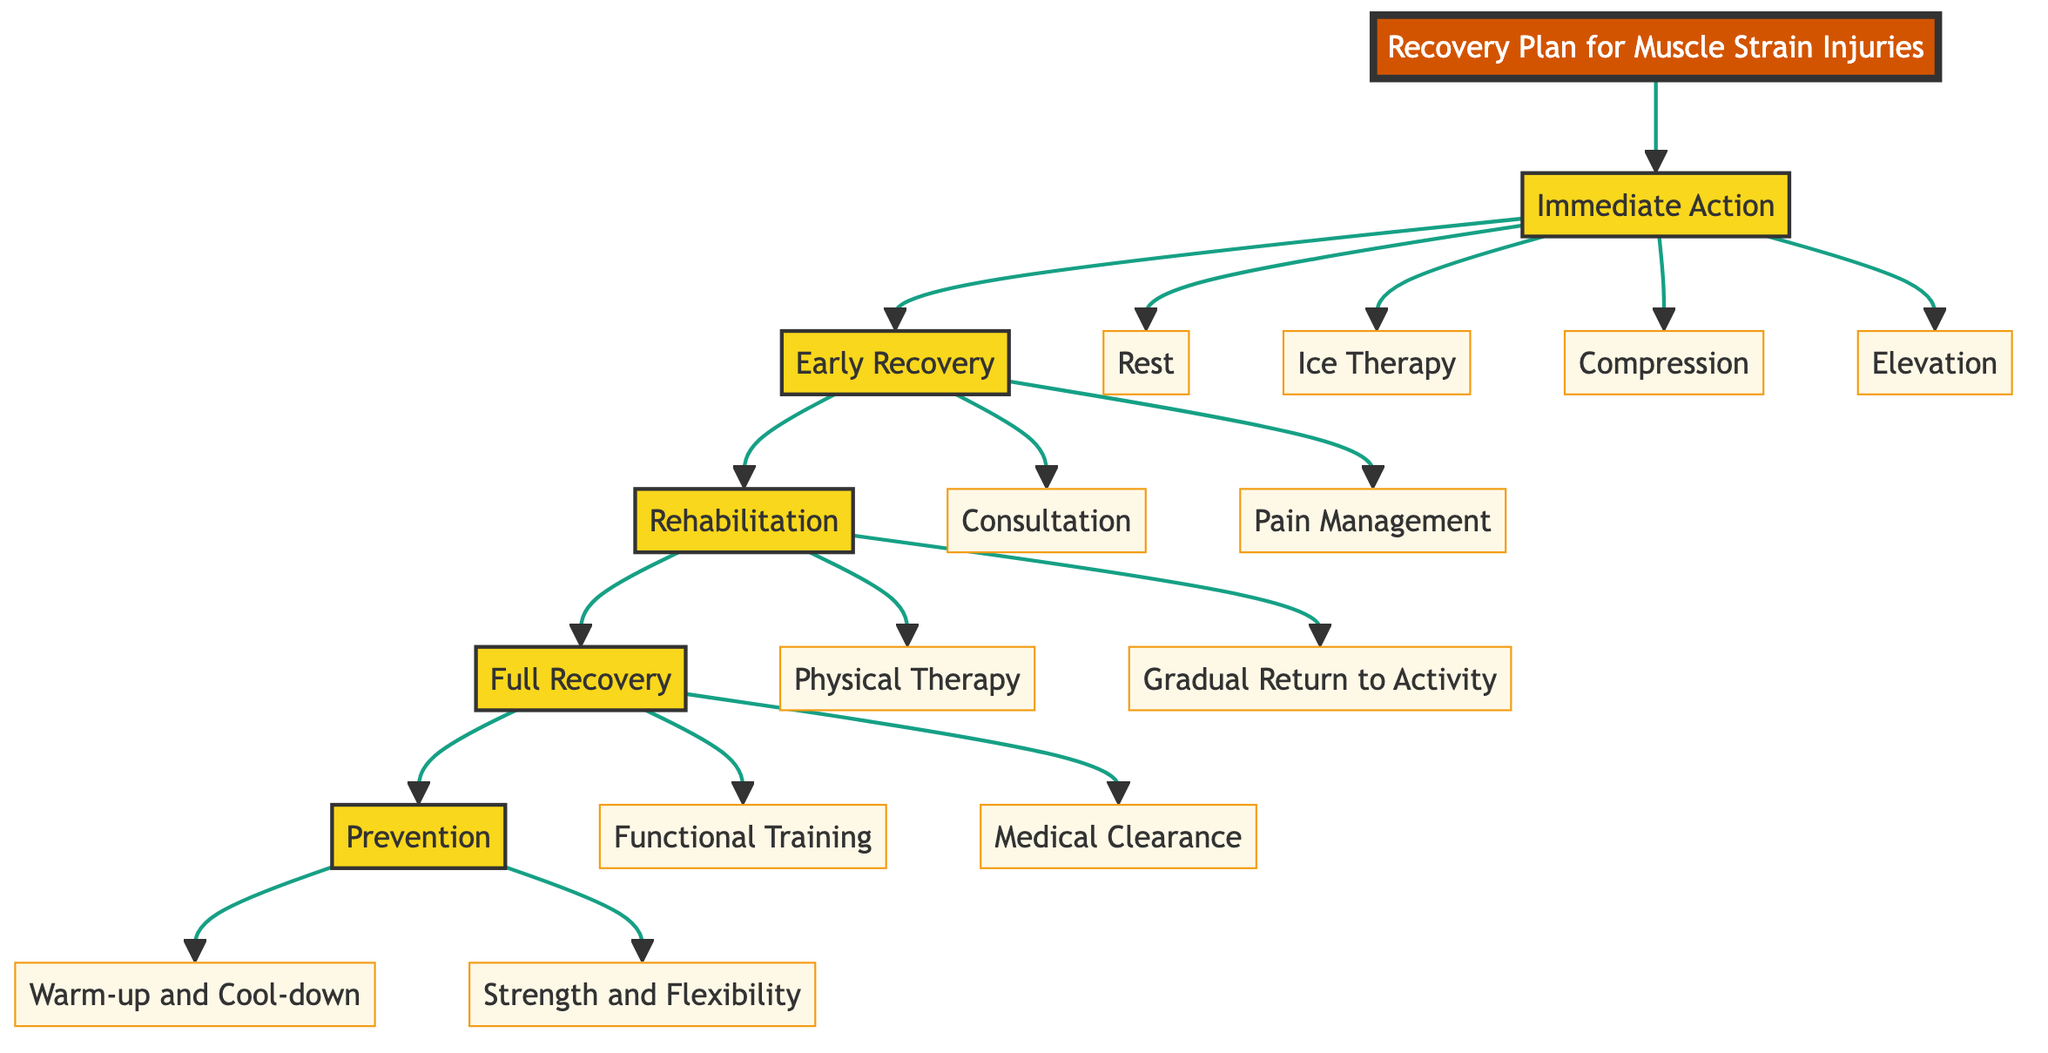What are the first four elements in the Immediate Action step? The Immediate Action step contains four elements: Rest, Ice Therapy, Compression, and Elevation. These elements are listed under the Immediate Action node in the diagram as the first set of actions to take.
Answer: Rest, Ice Therapy, Compression, Elevation How many steps does the Recovery Plan contain? The Recovery Plan includes five steps: Immediate Action, Early Recovery, Rehabilitation, Full Recovery, and Prevention. Each step represents a distinct phase in the recovery process.
Answer: Five Which step follows Early Recovery? The Rehabilitation step follows Early Recovery. This is evident from the flowchart structure that shows the progression from one step to the next in the Recovery Plan.
Answer: Rehabilitation What is the focus of the Full Recovery step? The Full Recovery step focuses on Functional Training and Medical Clearance. These elements emphasize the actions necessary for athletes to return to full wrestling activities safely.
Answer: Functional Training, Medical Clearance What should be done during the Early Recovery phase regarding pain? During the Early Recovery phase, Pain Management involves administering over-the-counter pain relievers like ibuprofen as needed. This action is intended to alleviate discomfort during recovery.
Answer: Pain Management What is the ultimate goal of the Prevention step? The ultimate goal of the Prevention step is to minimize the risk of future injuries. It achieves this through Warm-up and Cool-down routines, along with Strength and Flexibility exercises.
Answer: Minimize risk of future injuries Which element involves the athlete seeing a specialist? The element that involves the athlete seeing a specialist is Consultation, which is part of the Early Recovery step. This action is crucial for a thorough assessment by a sports medicine specialist.
Answer: Consultation What is the purpose of Elevation in Immediate Action? The purpose of Elevation in Immediate Action is to minimize swelling by keeping the injured limb above heart level. This helps reduce fluid accumulation in the injured area.
Answer: Minimize swelling 